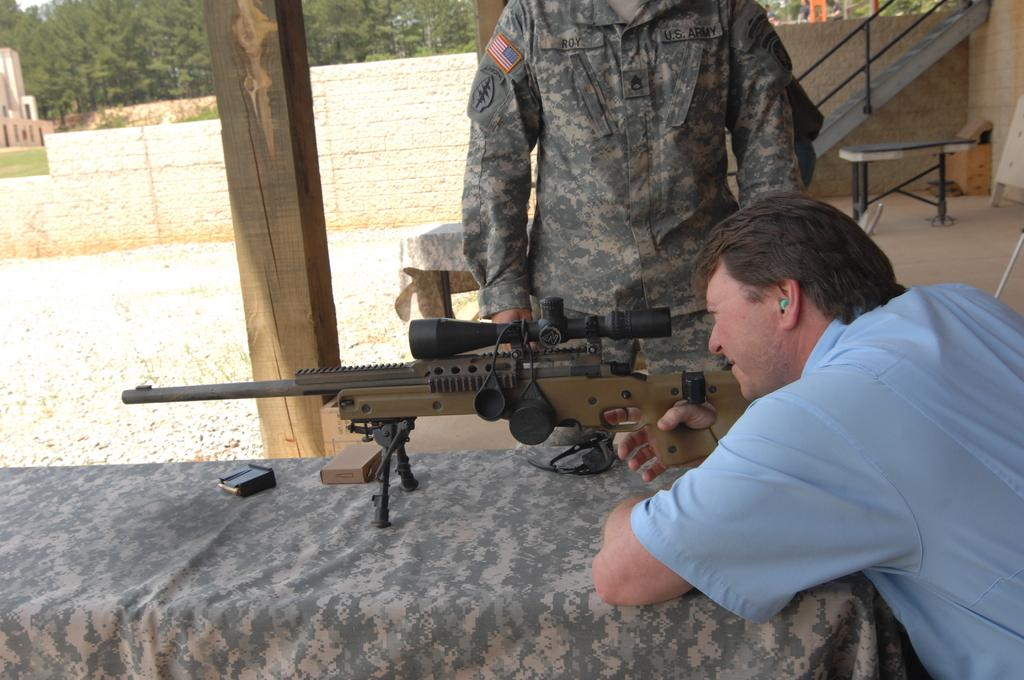What is the man in the image holding? The man in the image is holding a gun. Can you describe the other person in the image? There is another man standing in the image. What type of natural environment is visible in the image? There are trees in the image. What type of furniture is present in the image? There is a table in the image. What is the price of the artwork in the image? There is no artwork present in the image, so it is not possible to determine its price. How does the man holding the gun feel in the image? The image does not convey the emotions or feelings of the man holding the gun, so it is not possible to determine how he feels. 